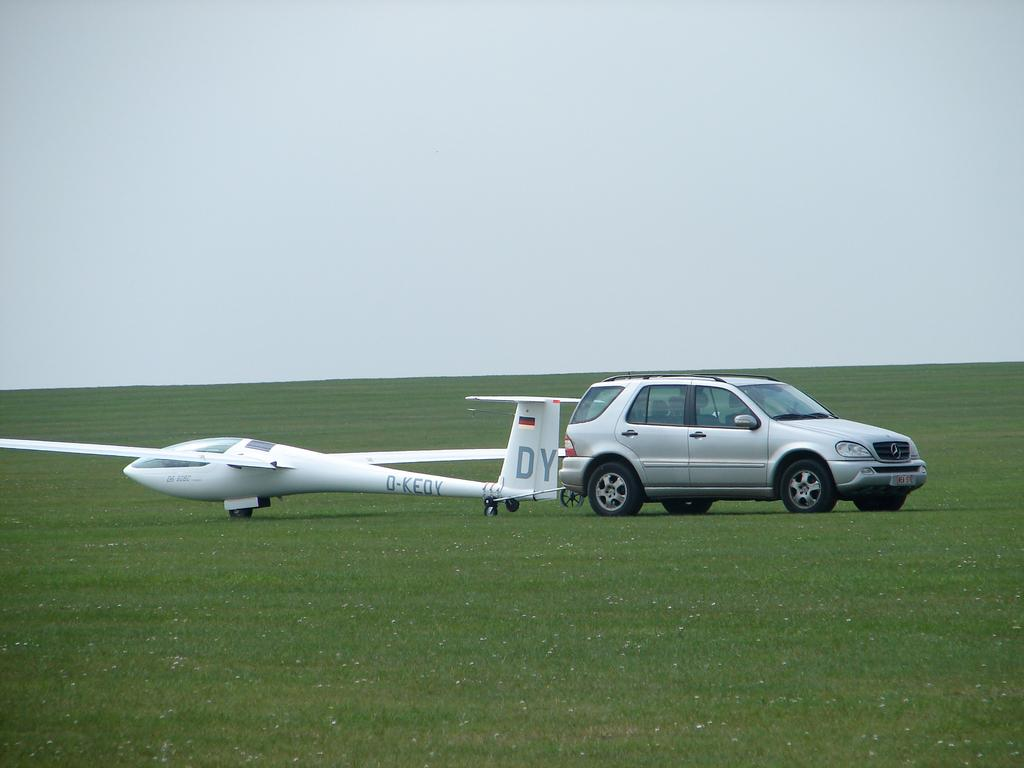<image>
Provide a brief description of the given image. On the back of the drone plane, the letters "DY" appear. 